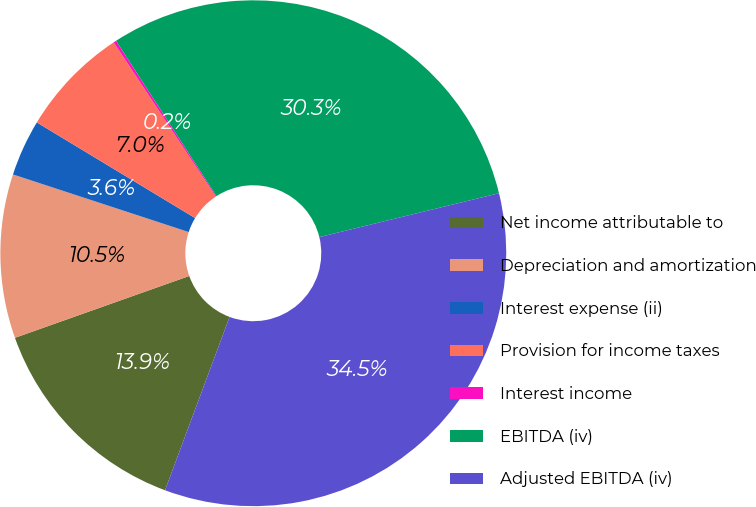<chart> <loc_0><loc_0><loc_500><loc_500><pie_chart><fcel>Net income attributable to<fcel>Depreciation and amortization<fcel>Interest expense (ii)<fcel>Provision for income taxes<fcel>Interest income<fcel>EBITDA (iv)<fcel>Adjusted EBITDA (iv)<nl><fcel>13.9%<fcel>10.47%<fcel>3.61%<fcel>7.04%<fcel>0.18%<fcel>30.32%<fcel>34.49%<nl></chart> 